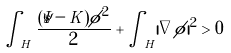Convert formula to latex. <formula><loc_0><loc_0><loc_500><loc_500>\int _ { H } \frac { ( \bar { s } - K ) \phi ^ { 2 } } 2 + \int _ { H } | \nabla \phi | ^ { 2 } > 0</formula> 